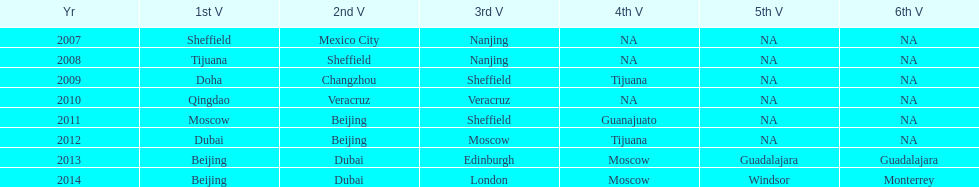In list of venues, how many years was beijing above moscow (1st venue is above 2nd venue, etc)? 3. Can you give me this table as a dict? {'header': ['Yr', '1st V', '2nd V', '3rd V', '4th V', '5th V', '6th V'], 'rows': [['2007', 'Sheffield', 'Mexico City', 'Nanjing', 'NA', 'NA', 'NA'], ['2008', 'Tijuana', 'Sheffield', 'Nanjing', 'NA', 'NA', 'NA'], ['2009', 'Doha', 'Changzhou', 'Sheffield', 'Tijuana', 'NA', 'NA'], ['2010', 'Qingdao', 'Veracruz', 'Veracruz', 'NA', 'NA', 'NA'], ['2011', 'Moscow', 'Beijing', 'Sheffield', 'Guanajuato', 'NA', 'NA'], ['2012', 'Dubai', 'Beijing', 'Moscow', 'Tijuana', 'NA', 'NA'], ['2013', 'Beijing', 'Dubai', 'Edinburgh', 'Moscow', 'Guadalajara', 'Guadalajara'], ['2014', 'Beijing', 'Dubai', 'London', 'Moscow', 'Windsor', 'Monterrey']]} 